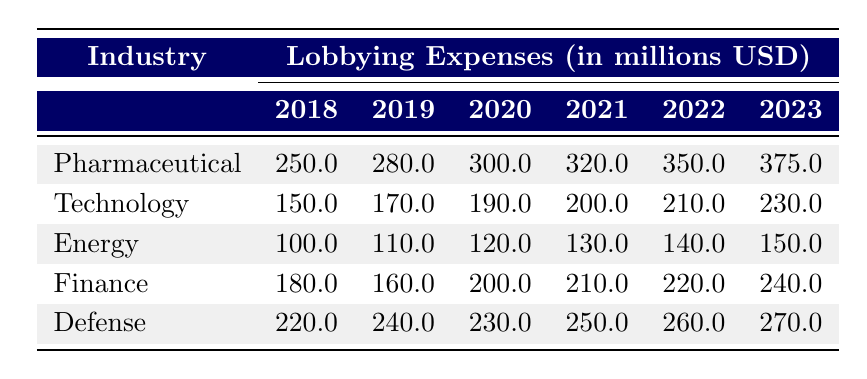What was the lobbying expense of the pharmaceutical industry in 2019? According to the table, the lobbying expense for the pharmaceutical industry in 2019 is explicitly listed as 280 million USD.
Answer: 280 million USD Which industry had the highest lobbying expenses in 2022? By looking at the 2022 column, the defense industry has the highest spending at 260 million USD, more than any other industry in that year.
Answer: Defense What is the total lobbying expense for technology from 2018 to 2023? The technology lobbying expenses for each year are: 150 (2018) + 170 (2019) + 190 (2020) + 200 (2021) + 210 (2022) + 230 (2023) = 1,150 million USD.
Answer: 1,150 million USD Did the lobbying expenses for the energy industry increase every year from 2018 to 2023? Looking at the energy industry, the amounts are 100 (2018), 110 (2019), 120 (2020), 130 (2021), 140 (2022), and 150 (2023), which shows a consistent increase each year.
Answer: Yes What was the average lobbying expense for the finance industry over the given years? The finance industry amounts are: 180 (2018), 160 (2019), 200 (2020), 210 (2021), 220 (2022), 240 (2023). The total is 1,210 million USD, and there are 6 data points, so the average is 1,210 / 6 = 201.67 million USD.
Answer: 201.67 million USD Was there any year in which the pharmaceutical industry spent less than the defense industry? The amounts for the pharmaceutical industry (250, 280, 300, 320, 350, 375) are always lower than those for the defense industry (220, 240, 230, 250, 260, 270) until 2023, when it surpasses the defense spending. In every year except for 2023, the pharmaceutical spending was less.
Answer: Yes What was the percentage increase of lobbying expenses for the technology industry from 2018 to 2023? The technology industry expenses increased from 150 million USD in 2018 to 230 million USD in 2023. The increase is 230 - 150 = 80 million USD, which is then a 53.33% increase calculated as (80 / 150) * 100.
Answer: 53.33% In 2020, what was the difference between the lobbying expenses of the pharmaceutical and energy industries? The pharmaceutical industry spent 300 million USD and energy spent 120 million USD in 2020. The difference is 300 - 120 = 180 million USD.
Answer: 180 million USD Which industry showed the largest increase in lobbying expenses from 2018 to 2023? The pharmaceutical industry increased from 250 million USD in 2018 to 375 million USD in 2023, showing an increase of 125 million USD, compared to other industries, which had smaller increases.
Answer: Pharmaceutical What was the total lobbying expense for all industries in 2021? Adding the expenses in 2021, we have: 320 (pharmaceutical) + 200 (technology) + 130 (energy) + 210 (finance) + 250 (defense) = 1,110 million USD.
Answer: 1,110 million USD 